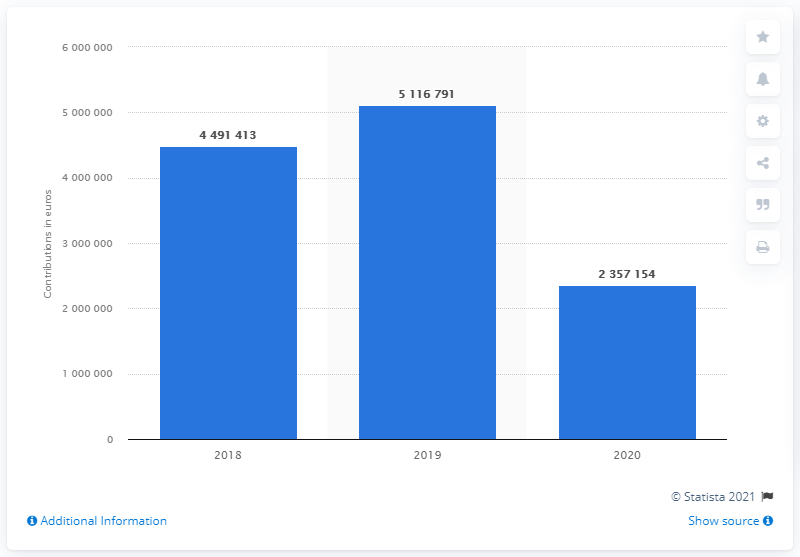Point out several critical features in this image. The amount of funding provided to Partito Democratico in the previous year was 51,167,910. 